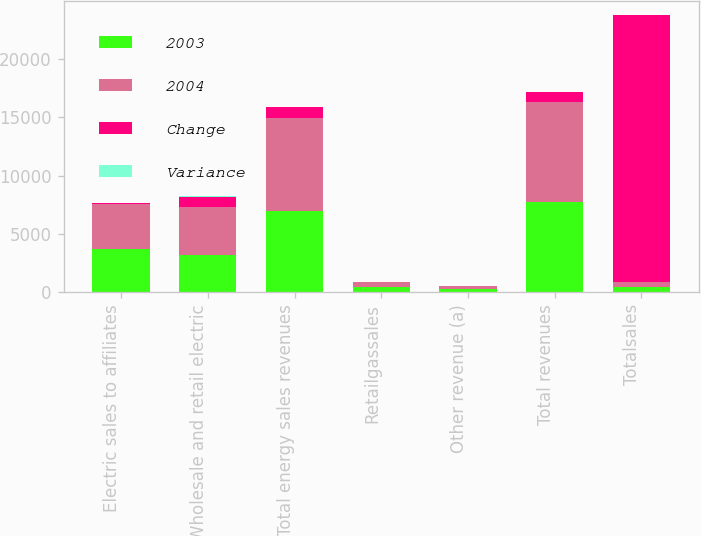<chart> <loc_0><loc_0><loc_500><loc_500><stacked_bar_chart><ecel><fcel>Electric sales to affiliates<fcel>Wholesale and retail electric<fcel>Total energy sales revenues<fcel>Retailgassales<fcel>Other revenue (a)<fcel>Total revenues<fcel>Totalsales<nl><fcel>2003<fcel>3749<fcel>3227<fcel>6976<fcel>448<fcel>279<fcel>7703<fcel>431<nl><fcel>2004<fcel>3831<fcel>4107<fcel>7938<fcel>414<fcel>233<fcel>8586<fcel>431<nl><fcel>Change<fcel>82<fcel>880<fcel>962<fcel>34<fcel>46<fcel>883<fcel>22905<nl><fcel>Variance<fcel>2.1<fcel>21.4<fcel>12.1<fcel>8.2<fcel>19.7<fcel>10.3<fcel>10.2<nl></chart> 